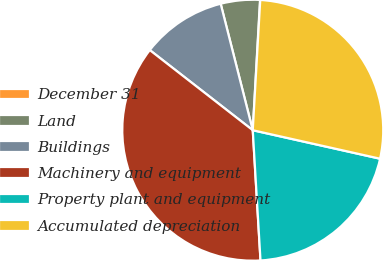<chart> <loc_0><loc_0><loc_500><loc_500><pie_chart><fcel>December 31<fcel>Land<fcel>Buildings<fcel>Machinery and equipment<fcel>Property plant and equipment<fcel>Accumulated depreciation<nl><fcel>0.03%<fcel>4.84%<fcel>10.52%<fcel>36.47%<fcel>20.55%<fcel>27.59%<nl></chart> 